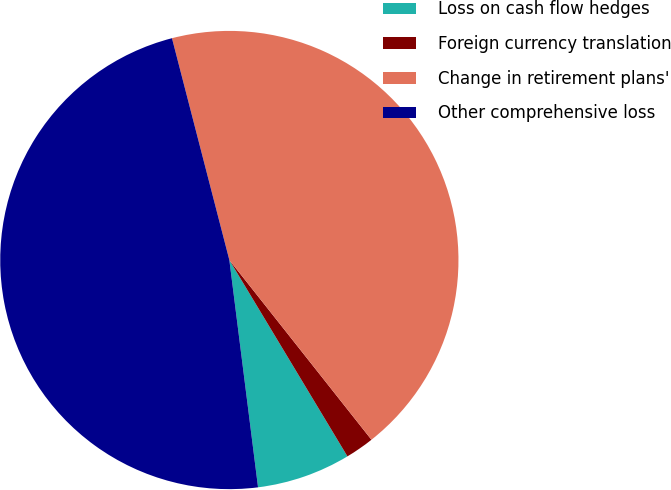<chart> <loc_0><loc_0><loc_500><loc_500><pie_chart><fcel>Loss on cash flow hedges<fcel>Foreign currency translation<fcel>Change in retirement plans'<fcel>Other comprehensive loss<nl><fcel>6.62%<fcel>2.03%<fcel>43.38%<fcel>47.97%<nl></chart> 